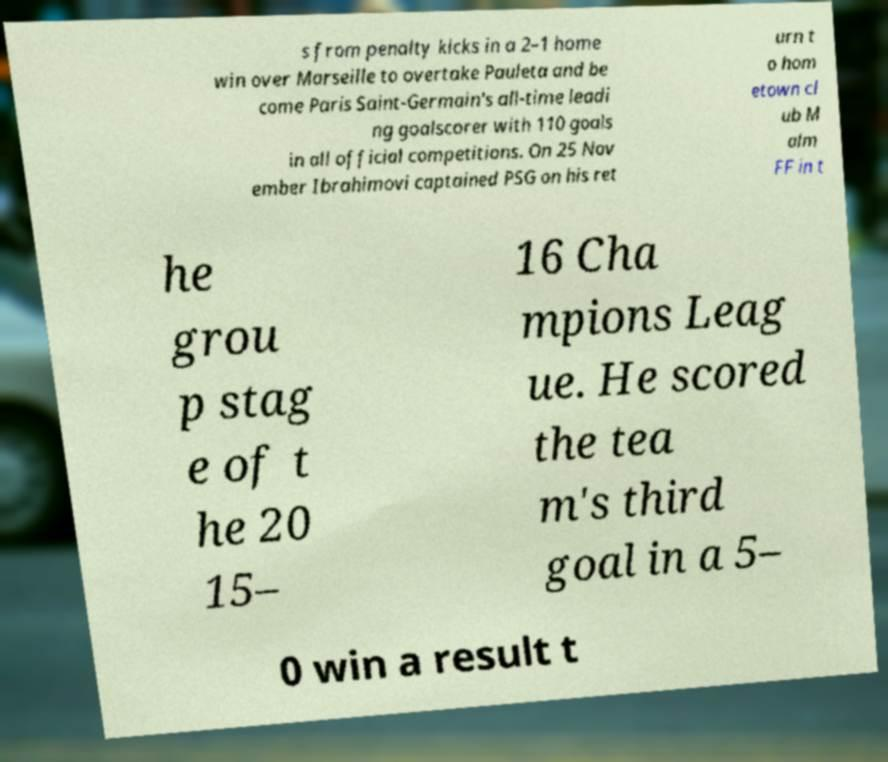I need the written content from this picture converted into text. Can you do that? s from penalty kicks in a 2–1 home win over Marseille to overtake Pauleta and be come Paris Saint-Germain's all-time leadi ng goalscorer with 110 goals in all official competitions. On 25 Nov ember Ibrahimovi captained PSG on his ret urn t o hom etown cl ub M alm FF in t he grou p stag e of t he 20 15– 16 Cha mpions Leag ue. He scored the tea m's third goal in a 5– 0 win a result t 